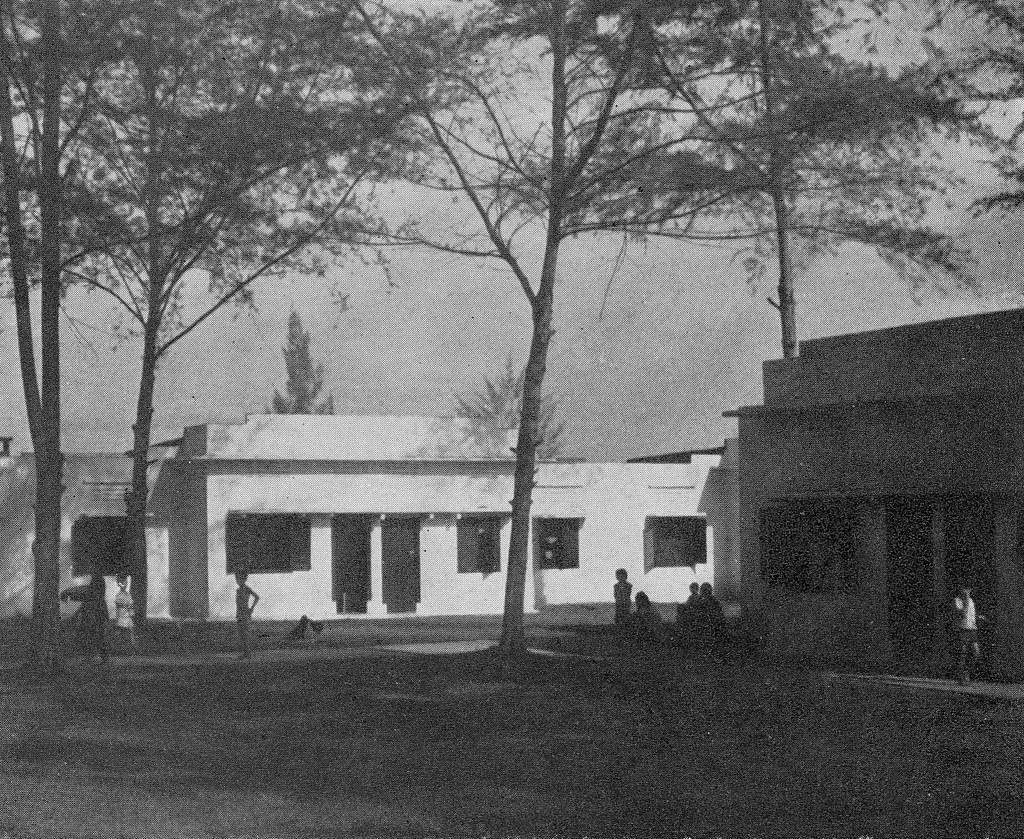Can you describe this image briefly? As we can see in the image there are houses, windows, few people here and there, trees and sky. The image is little dark. 